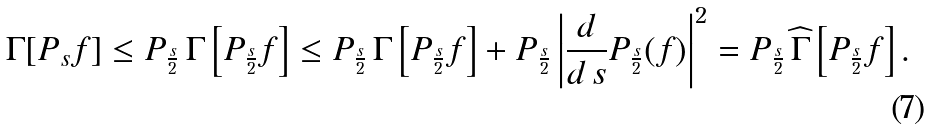<formula> <loc_0><loc_0><loc_500><loc_500>\Gamma [ P _ { s } f ] \leq P _ { \frac { s } { 2 } } \, \Gamma \left [ P _ { \frac { s } { 2 } } f \right ] \leq P _ { \frac { s } { 2 } } \, \Gamma \left [ P _ { \frac { s } { 2 } } f \right ] + P _ { \frac { s } { 2 } } \left | \frac { d } { d \, s } P _ { \frac { s } { 2 } } ( f ) \right | ^ { 2 } = P _ { \frac { s } { 2 } } \, \widehat { \Gamma } \left [ P _ { \frac { s } { 2 } } f \right ] .</formula> 